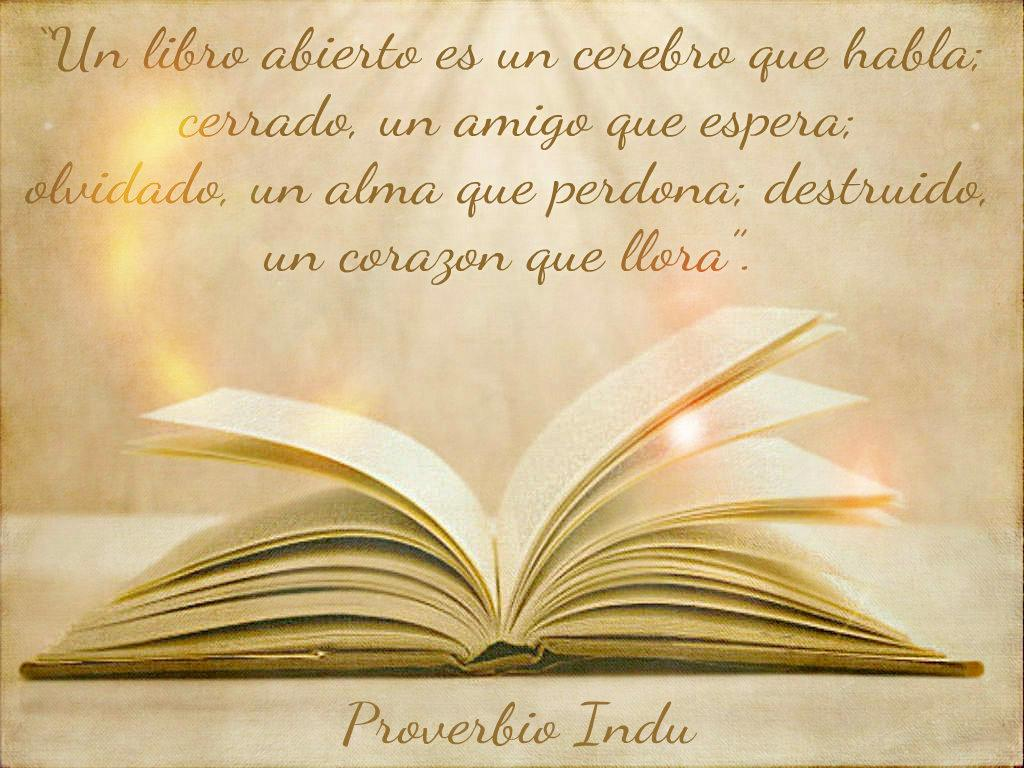<image>
Give a short and clear explanation of the subsequent image. A goldish open book Proverbio Indu with some quotes 